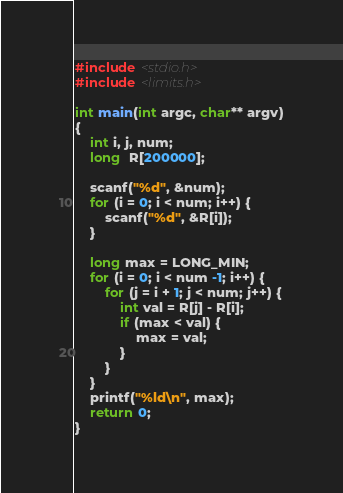Convert code to text. <code><loc_0><loc_0><loc_500><loc_500><_C_>#include <stdio.h>
#include <limits.h>

int main(int argc, char** argv)
{
	int i, j, num;
	long  R[200000];

	scanf("%d", &num);
	for (i = 0; i < num; i++) {
		scanf("%d", &R[i]);
	}

	long max = LONG_MIN;
	for (i = 0; i < num -1; i++) {
		for (j = i + 1; j < num; j++) {
			int val = R[j] - R[i];
			if (max < val) {
				max = val;
			}
		}
	}
	printf("%ld\n", max);
	return 0;
}</code> 